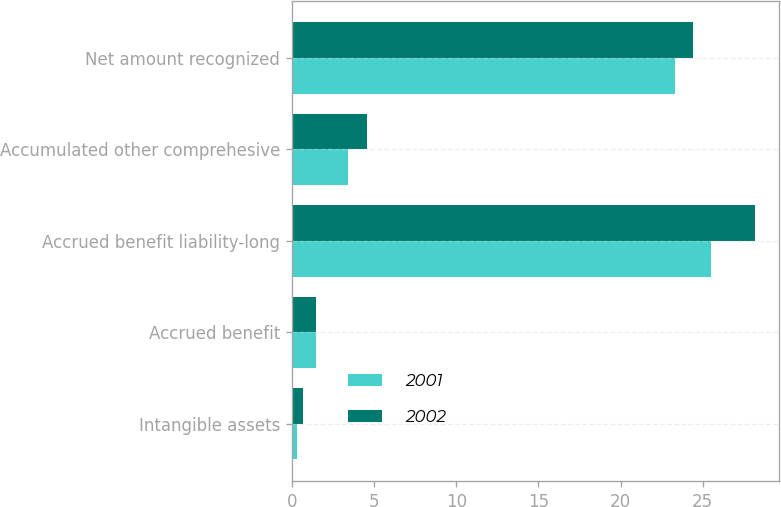Convert chart to OTSL. <chart><loc_0><loc_0><loc_500><loc_500><stacked_bar_chart><ecel><fcel>Intangible assets<fcel>Accrued benefit<fcel>Accrued benefit liability-long<fcel>Accumulated other comprehesive<fcel>Net amount recognized<nl><fcel>2001<fcel>0.3<fcel>1.5<fcel>25.5<fcel>3.4<fcel>23.3<nl><fcel>2002<fcel>0.7<fcel>1.5<fcel>28.2<fcel>4.6<fcel>24.4<nl></chart> 